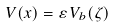<formula> <loc_0><loc_0><loc_500><loc_500>V ( x ) = \varepsilon \, V _ { b } ( \zeta )</formula> 